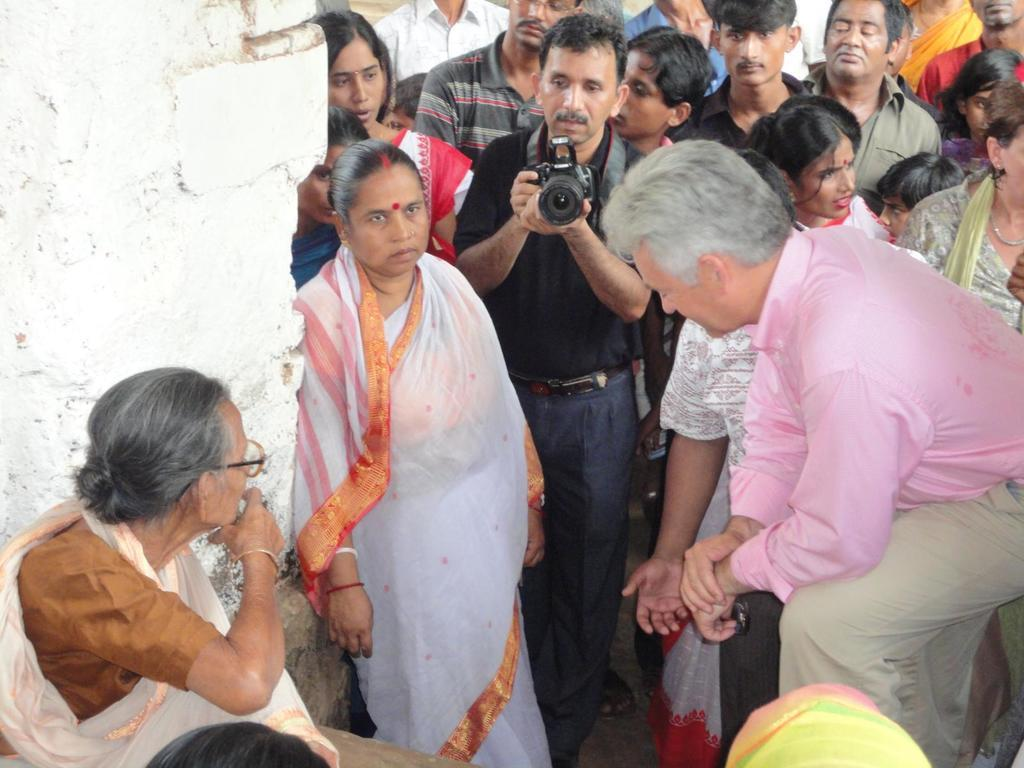What can be seen in the image? There is a group of people in the image. What is on the left side of the image? There is a wall on the left side of the image. Can you describe one of the people in the image? There is a woman wearing spectacles in the image. What is the man in the image holding? There is a man holding a camera in the image. What type of quill is the man using to write on the cork in the image? There is no man using a quill to write on a cork in the image; these items are not present. 